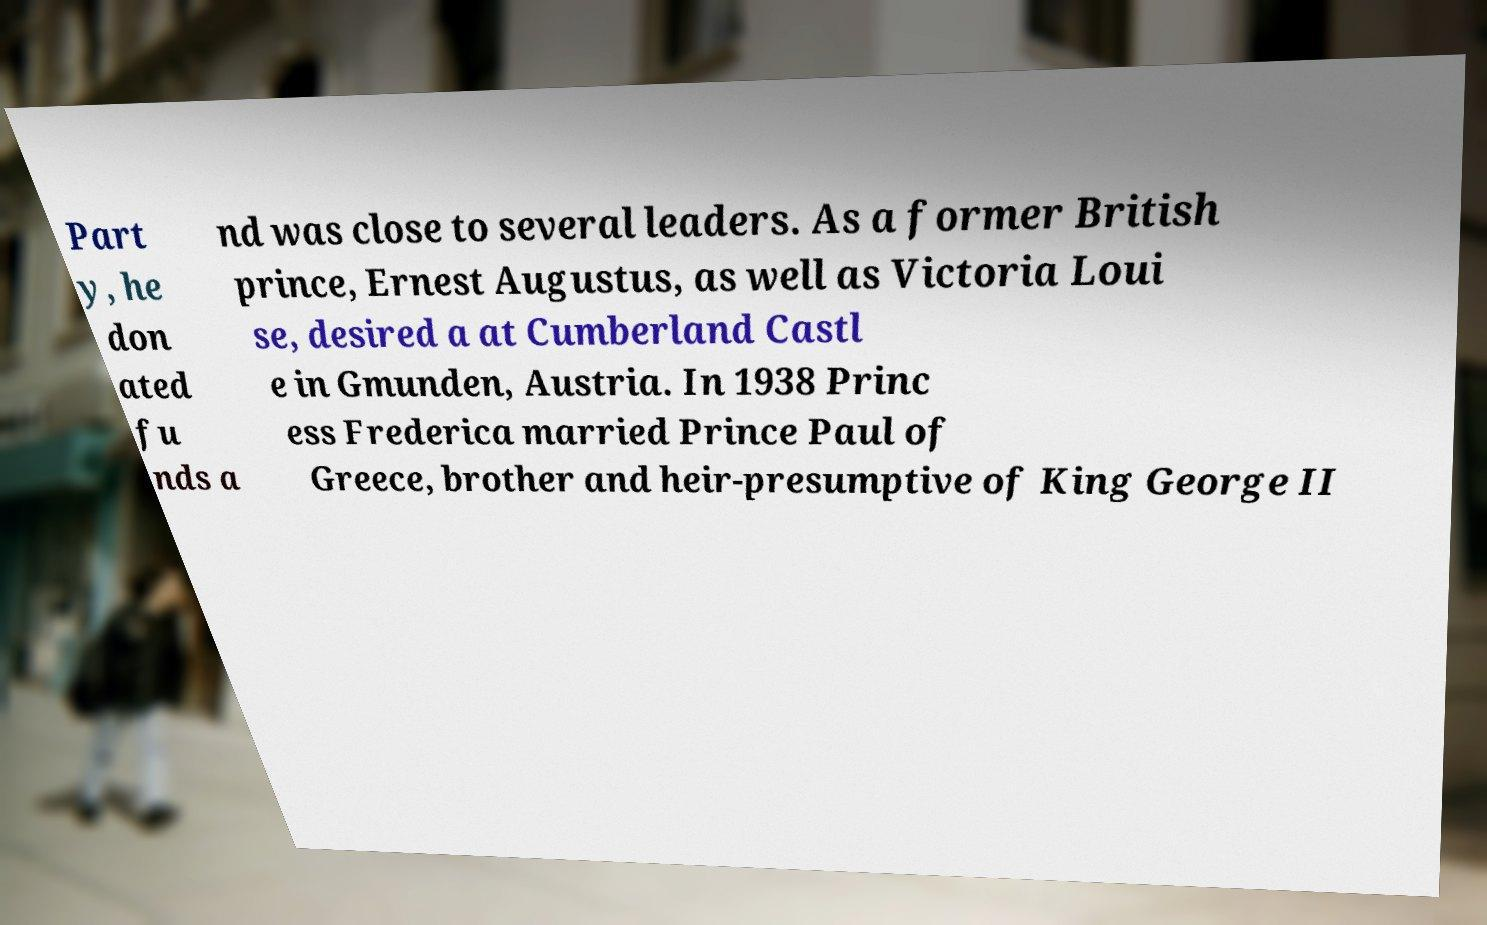Can you read and provide the text displayed in the image?This photo seems to have some interesting text. Can you extract and type it out for me? Part y, he don ated fu nds a nd was close to several leaders. As a former British prince, Ernest Augustus, as well as Victoria Loui se, desired a at Cumberland Castl e in Gmunden, Austria. In 1938 Princ ess Frederica married Prince Paul of Greece, brother and heir-presumptive of King George II 